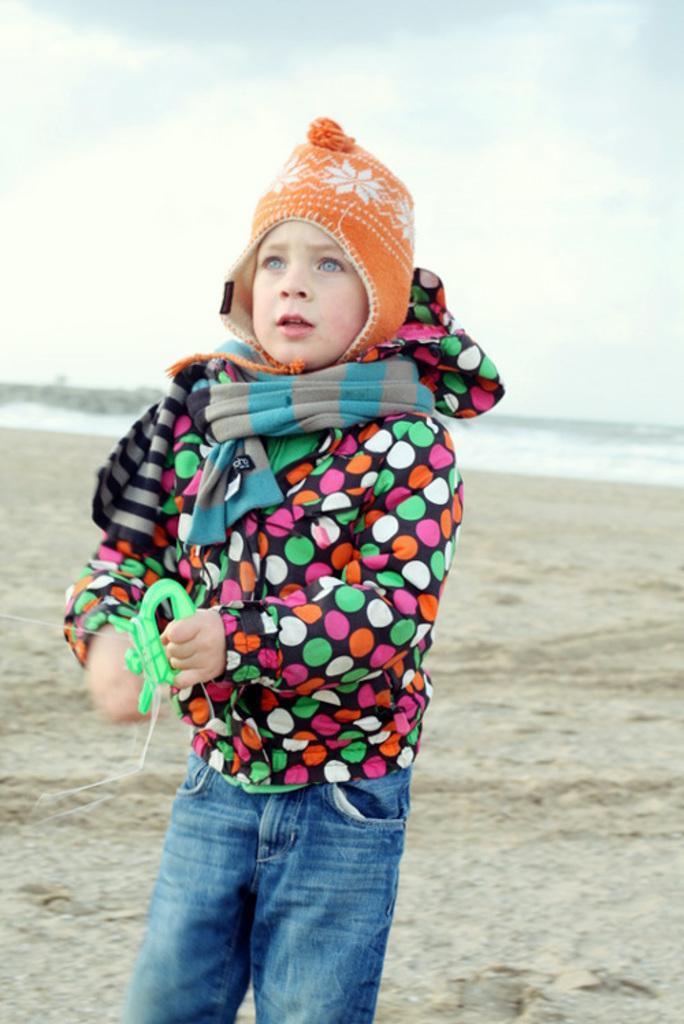Can you describe this image briefly? In this picture we can see a boy wore a cap and standing on the ground and in the background we can see the sky with clouds. 